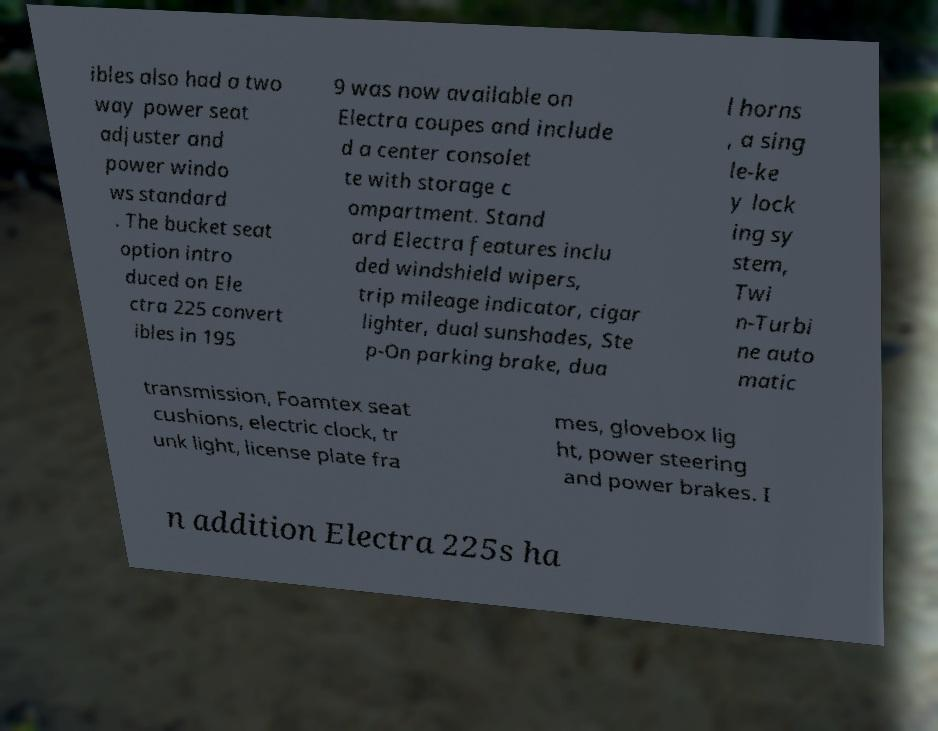What messages or text are displayed in this image? I need them in a readable, typed format. ibles also had a two way power seat adjuster and power windo ws standard . The bucket seat option intro duced on Ele ctra 225 convert ibles in 195 9 was now available on Electra coupes and include d a center consolet te with storage c ompartment. Stand ard Electra features inclu ded windshield wipers, trip mileage indicator, cigar lighter, dual sunshades, Ste p-On parking brake, dua l horns , a sing le-ke y lock ing sy stem, Twi n-Turbi ne auto matic transmission, Foamtex seat cushions, electric clock, tr unk light, license plate fra mes, glovebox lig ht, power steering and power brakes. I n addition Electra 225s ha 